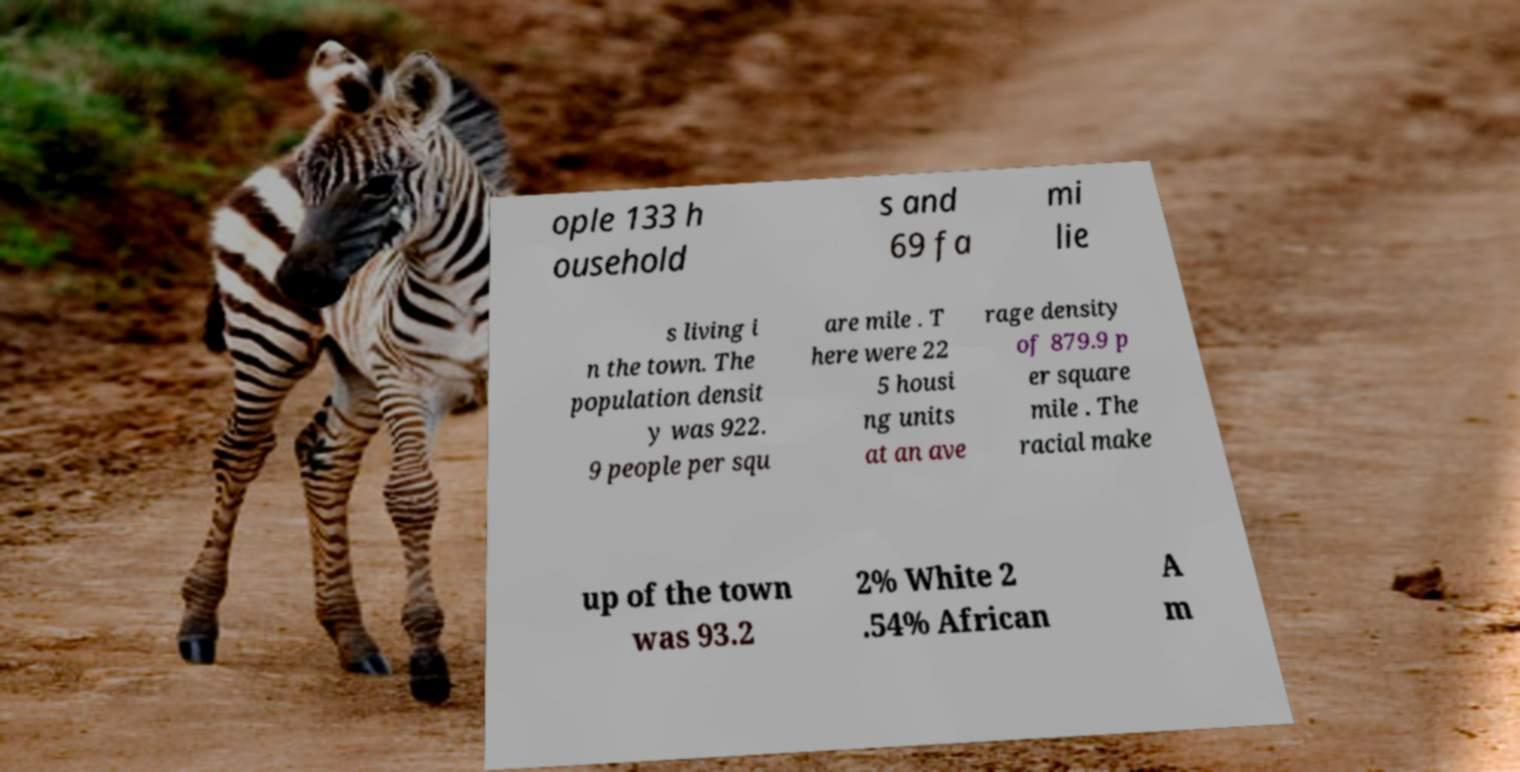I need the written content from this picture converted into text. Can you do that? ople 133 h ousehold s and 69 fa mi lie s living i n the town. The population densit y was 922. 9 people per squ are mile . T here were 22 5 housi ng units at an ave rage density of 879.9 p er square mile . The racial make up of the town was 93.2 2% White 2 .54% African A m 